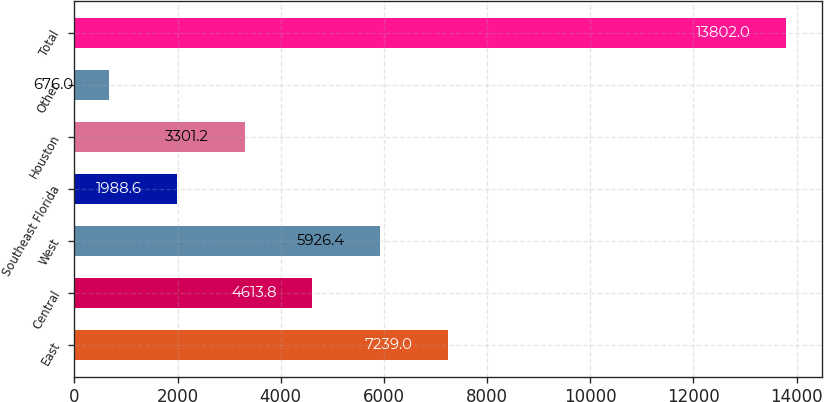Convert chart to OTSL. <chart><loc_0><loc_0><loc_500><loc_500><bar_chart><fcel>East<fcel>Central<fcel>West<fcel>Southeast Florida<fcel>Houston<fcel>Other<fcel>Total<nl><fcel>7239<fcel>4613.8<fcel>5926.4<fcel>1988.6<fcel>3301.2<fcel>676<fcel>13802<nl></chart> 